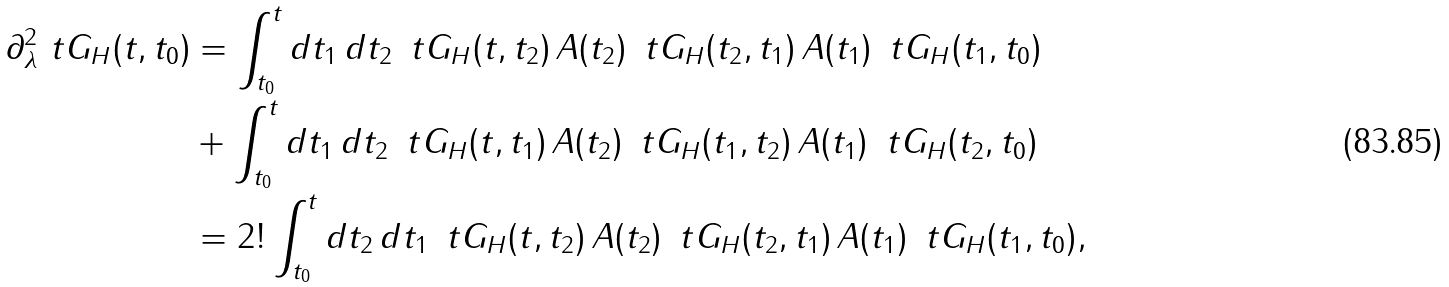Convert formula to latex. <formula><loc_0><loc_0><loc_500><loc_500>\partial ^ { 2 } _ { \lambda } \ t G _ { H } ( t , t _ { 0 } ) & = \int _ { t _ { 0 } } ^ { t } d t _ { 1 } \, d t _ { 2 } \, \ t G _ { H } ( t , t _ { 2 } ) \, { A } ( t _ { 2 } ) \, \ t G _ { H } ( t _ { 2 } , t _ { 1 } ) \, { A } ( t _ { 1 } ) \, \ t G _ { H } ( t _ { 1 } , t _ { 0 } ) \\ & + \int _ { t _ { 0 } } ^ { t } d t _ { 1 } \, d t _ { 2 } \, \ t G _ { H } ( t , t _ { 1 } ) \, { A } ( t _ { 2 } ) \, \ t G _ { H } ( t _ { 1 } , t _ { 2 } ) \, { A } ( t _ { 1 } ) \, \ t G _ { H } ( t _ { 2 } , t _ { 0 } ) \\ & = 2 ! \int _ { t _ { 0 } } ^ { t } d t _ { 2 } \, d t _ { 1 } \, \ t G _ { H } ( t , t _ { 2 } ) \, { A } ( t _ { 2 } ) \, \ t G _ { H } ( t _ { 2 } , t _ { 1 } ) \, { A } ( t _ { 1 } ) \, \ t G _ { H } ( t _ { 1 } , t _ { 0 } ) ,</formula> 